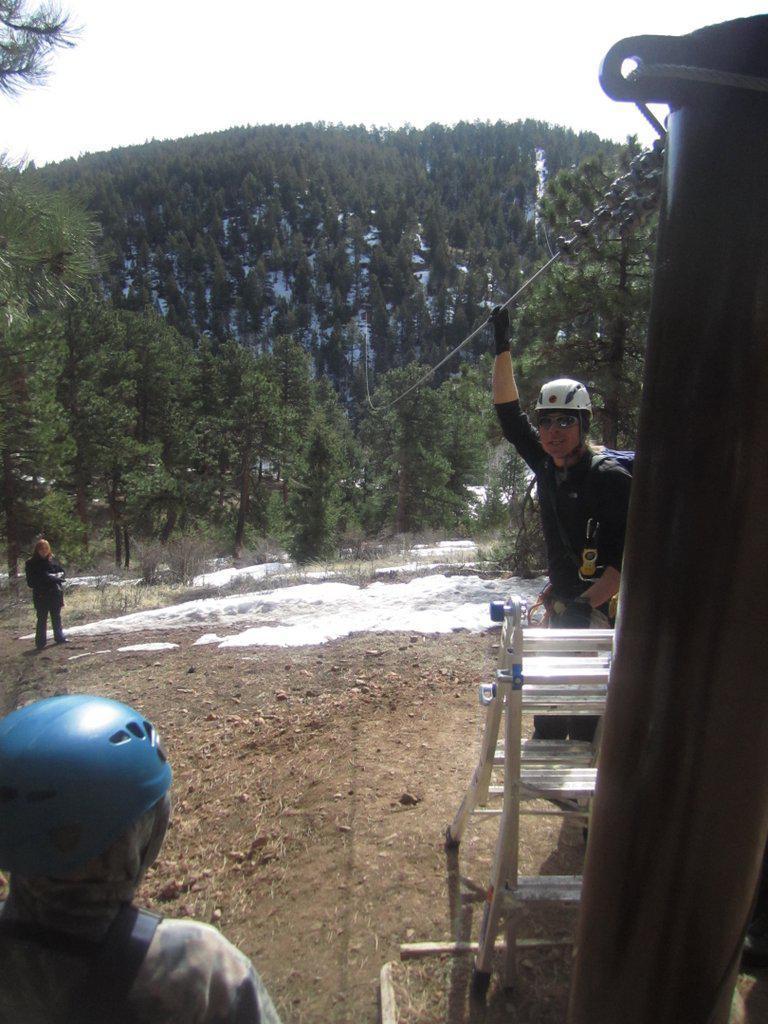Please provide a concise description of this image. In this image we can see persons standing on the ground, ladder, pole, chain, cable, trees and sky. 